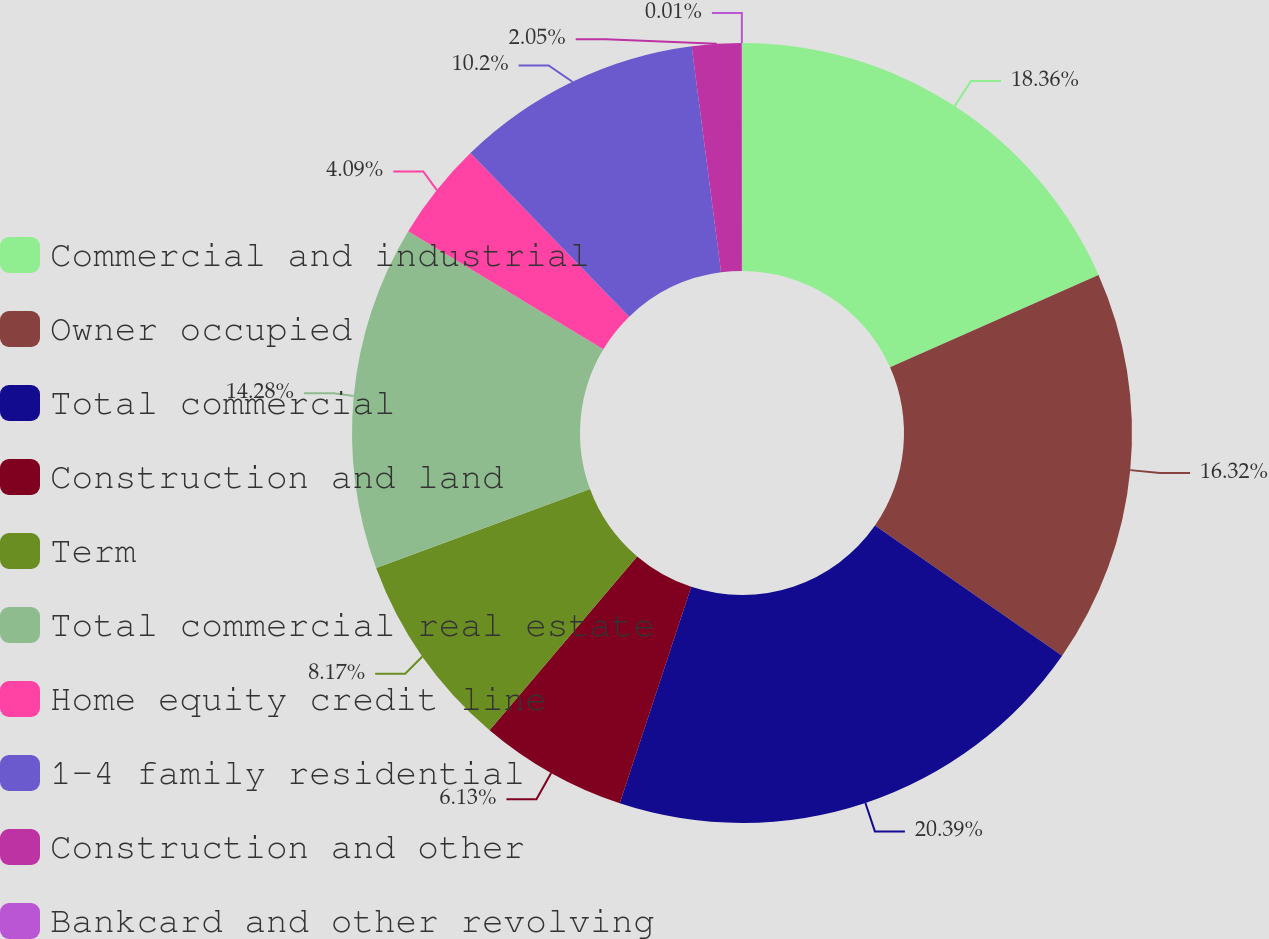<chart> <loc_0><loc_0><loc_500><loc_500><pie_chart><fcel>Commercial and industrial<fcel>Owner occupied<fcel>Total commercial<fcel>Construction and land<fcel>Term<fcel>Total commercial real estate<fcel>Home equity credit line<fcel>1-4 family residential<fcel>Construction and other<fcel>Bankcard and other revolving<nl><fcel>18.36%<fcel>16.32%<fcel>20.4%<fcel>6.13%<fcel>8.17%<fcel>14.28%<fcel>4.09%<fcel>10.2%<fcel>2.05%<fcel>0.01%<nl></chart> 